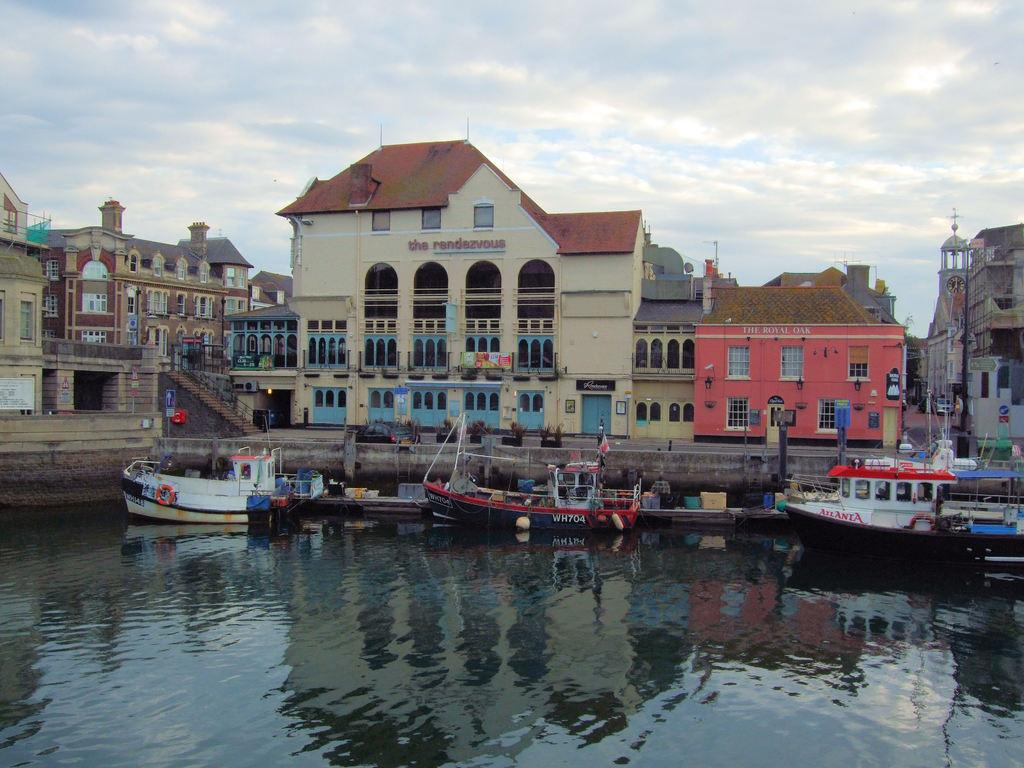What type of vehicles can be seen on the water in the image? There are boats on the water in the image. What architectural features can be seen in the background of the image? There are buildings with windows, arches, and doors in the background. What type of structure can be seen in the background of the image? There are steps with railings in the background. What is visible in the sky in the image? The sky is visible in the background of the image. What type of mountain can be seen in the image? There is no mountain present in the image. What is the condition of the tank in the image? There is no tank present in the image. 